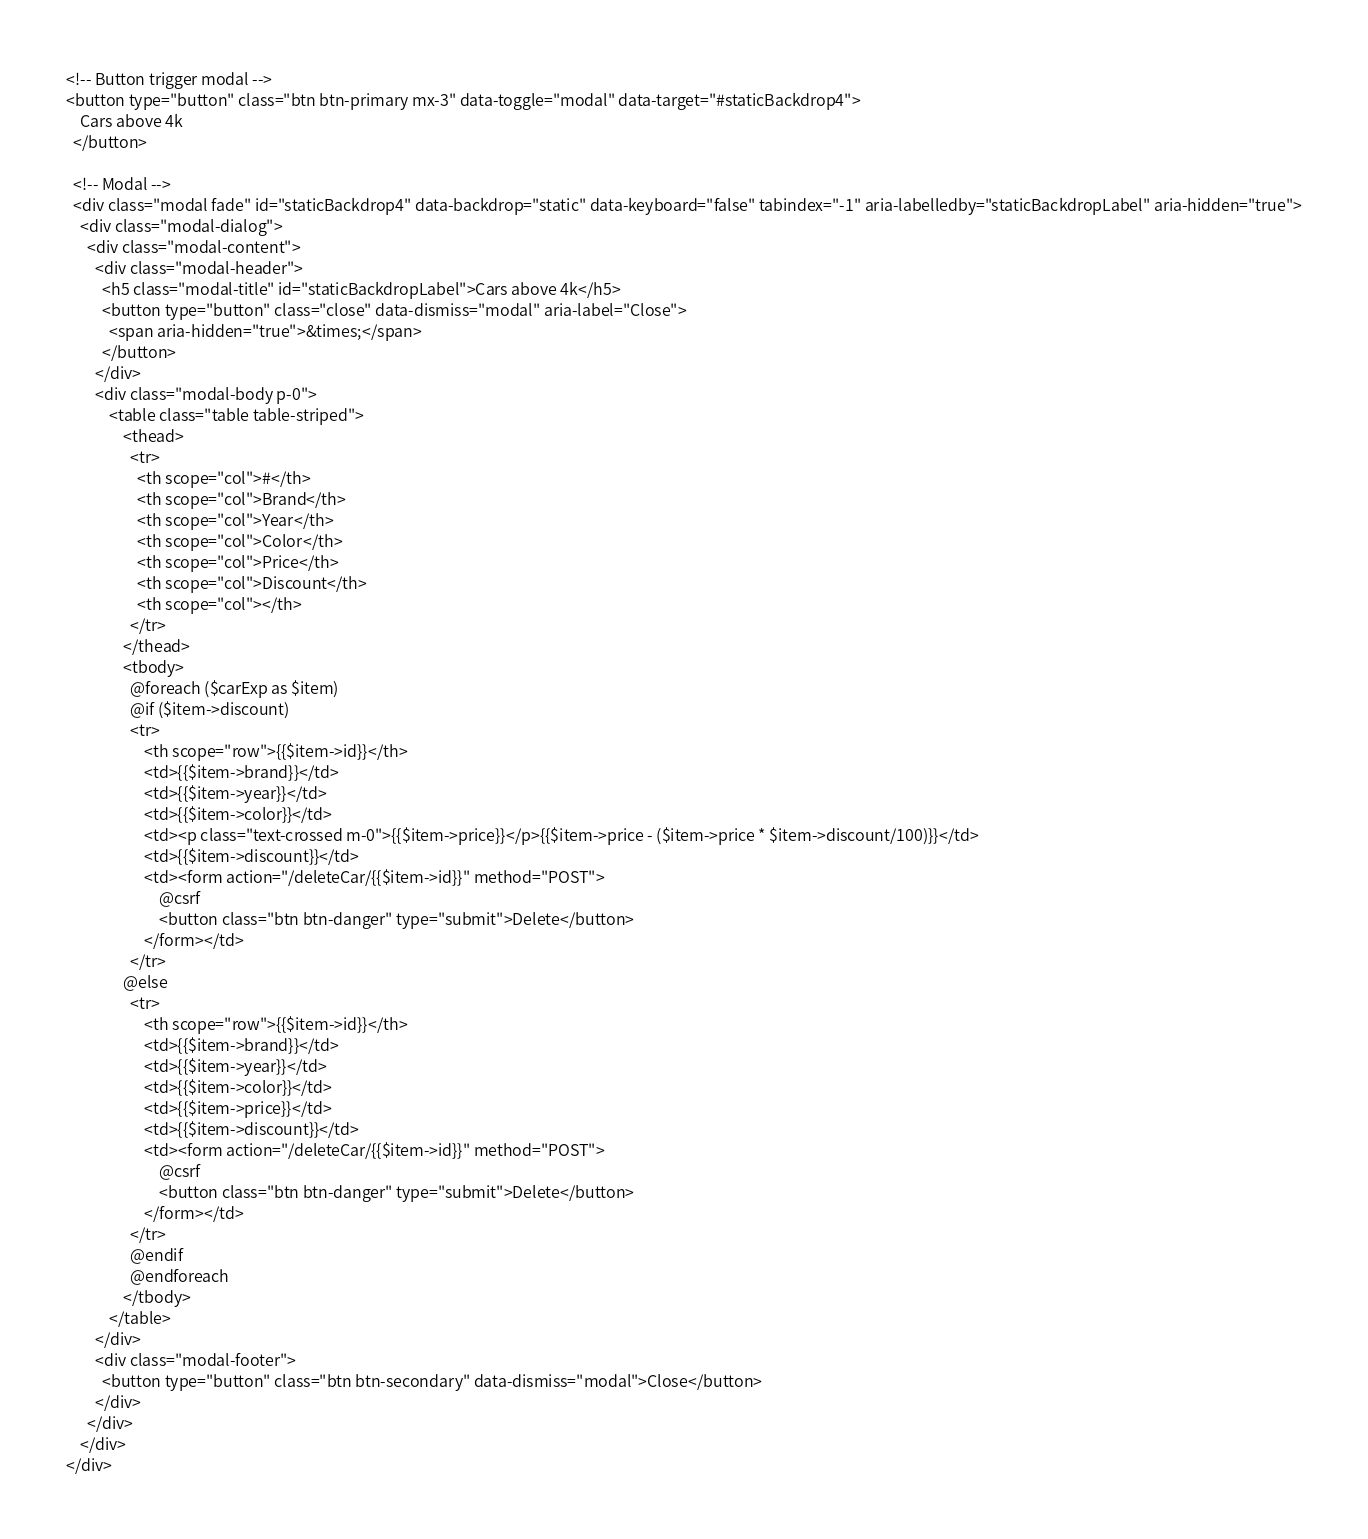<code> <loc_0><loc_0><loc_500><loc_500><_PHP_><!-- Button trigger modal -->
<button type="button" class="btn btn-primary mx-3" data-toggle="modal" data-target="#staticBackdrop4">
    Cars above 4k
  </button>
  
  <!-- Modal -->
  <div class="modal fade" id="staticBackdrop4" data-backdrop="static" data-keyboard="false" tabindex="-1" aria-labelledby="staticBackdropLabel" aria-hidden="true">
    <div class="modal-dialog">
      <div class="modal-content">
        <div class="modal-header">
          <h5 class="modal-title" id="staticBackdropLabel">Cars above 4k</h5>
          <button type="button" class="close" data-dismiss="modal" aria-label="Close">
            <span aria-hidden="true">&times;</span>
          </button>
        </div>
        <div class="modal-body p-0">
            <table class="table table-striped">
                <thead>
                  <tr>
                    <th scope="col">#</th>
                    <th scope="col">Brand</th>
                    <th scope="col">Year</th>
                    <th scope="col">Color</th>
                    <th scope="col">Price</th>
                    <th scope="col">Discount</th>
                    <th scope="col"></th>
                  </tr>
                </thead>
                <tbody>
                  @foreach ($carExp as $item)
                  @if ($item->discount)
                  <tr>
                      <th scope="row">{{$item->id}}</th>
                      <td>{{$item->brand}}</td>
                      <td>{{$item->year}}</td>
                      <td>{{$item->color}}</td>
                      <td><p class="text-crossed m-0">{{$item->price}}</p>{{$item->price - ($item->price * $item->discount/100)}}</td>
                      <td>{{$item->discount}}</td>
                      <td><form action="/deleteCar/{{$item->id}}" method="POST">
                          @csrf
                          <button class="btn btn-danger" type="submit">Delete</button>
                      </form></td>
                  </tr>
                @else
                  <tr>
                      <th scope="row">{{$item->id}}</th>
                      <td>{{$item->brand}}</td>
                      <td>{{$item->year}}</td>
                      <td>{{$item->color}}</td>
                      <td>{{$item->price}}</td>
                      <td>{{$item->discount}}</td>
                      <td><form action="/deleteCar/{{$item->id}}" method="POST">
                          @csrf
                          <button class="btn btn-danger" type="submit">Delete</button>
                      </form></td>
                  </tr>
                  @endif
                  @endforeach
                </tbody>
            </table>
        </div>
        <div class="modal-footer">
          <button type="button" class="btn btn-secondary" data-dismiss="modal">Close</button>
        </div>
      </div>
    </div>
</div></code> 